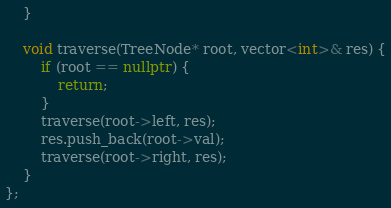<code> <loc_0><loc_0><loc_500><loc_500><_C++_>    }
    
    void traverse(TreeNode* root, vector<int>& res) {
        if (root == nullptr) {
            return;
        }
        traverse(root->left, res);
        res.push_back(root->val);
        traverse(root->right, res);
    }
};
</code> 